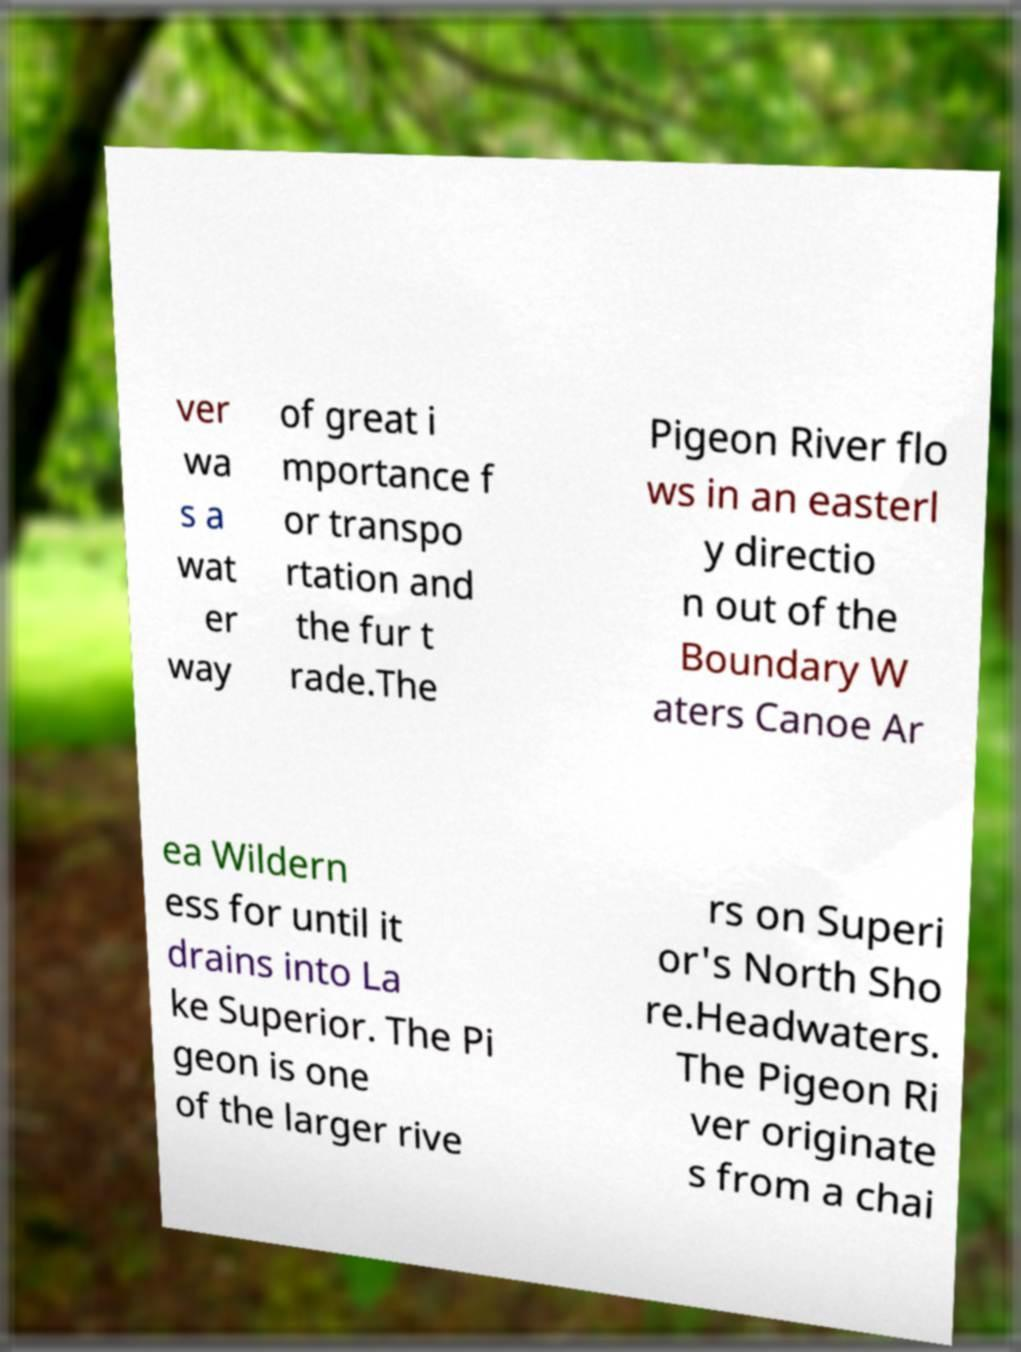Please read and relay the text visible in this image. What does it say? ver wa s a wat er way of great i mportance f or transpo rtation and the fur t rade.The Pigeon River flo ws in an easterl y directio n out of the Boundary W aters Canoe Ar ea Wildern ess for until it drains into La ke Superior. The Pi geon is one of the larger rive rs on Superi or's North Sho re.Headwaters. The Pigeon Ri ver originate s from a chai 